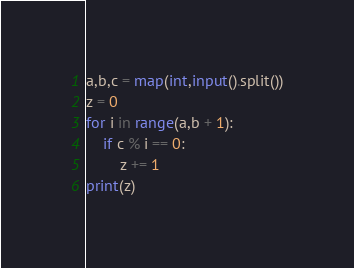<code> <loc_0><loc_0><loc_500><loc_500><_Python_>a,b,c = map(int,input().split())
z = 0
for i in range(a,b + 1):
    if c % i == 0:
        z += 1
print(z)
</code> 